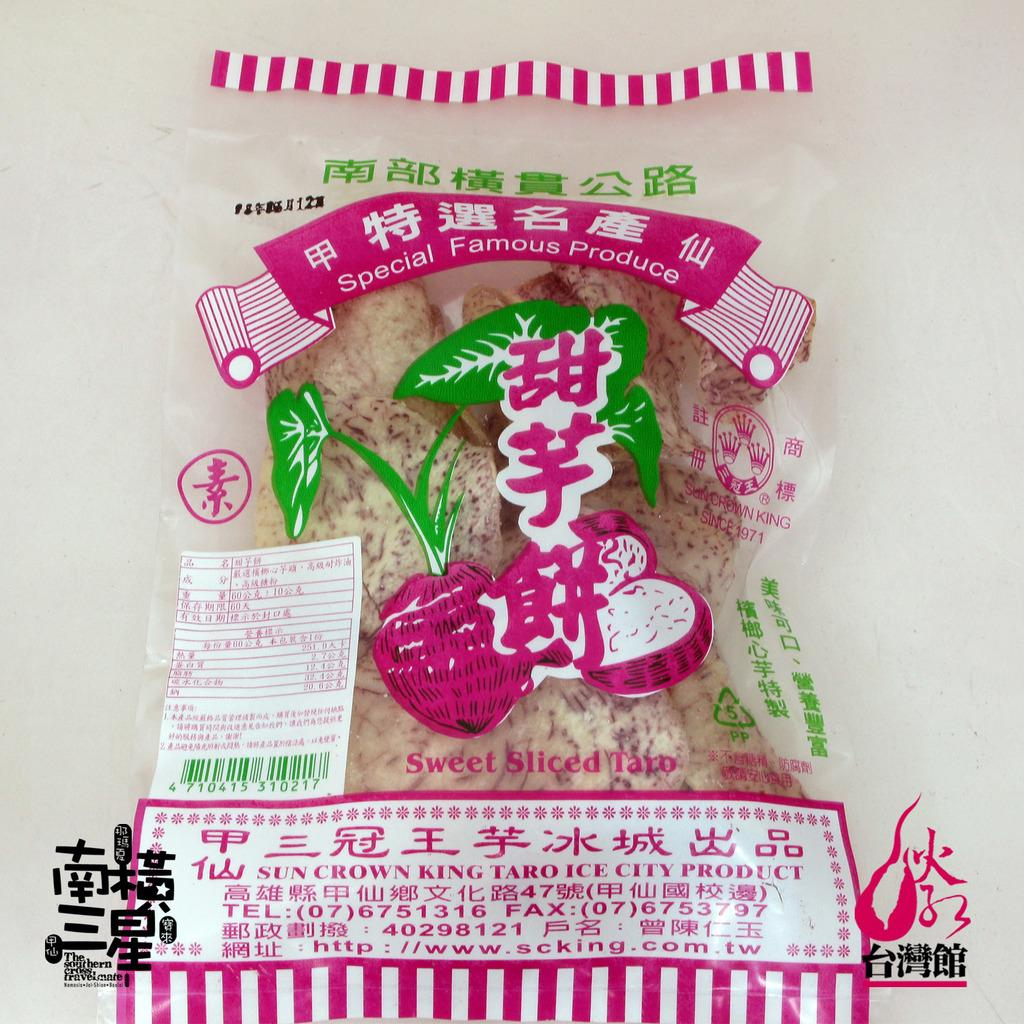<image>
Describe the image concisely. A pink and white package of food from Sun Crown King. 